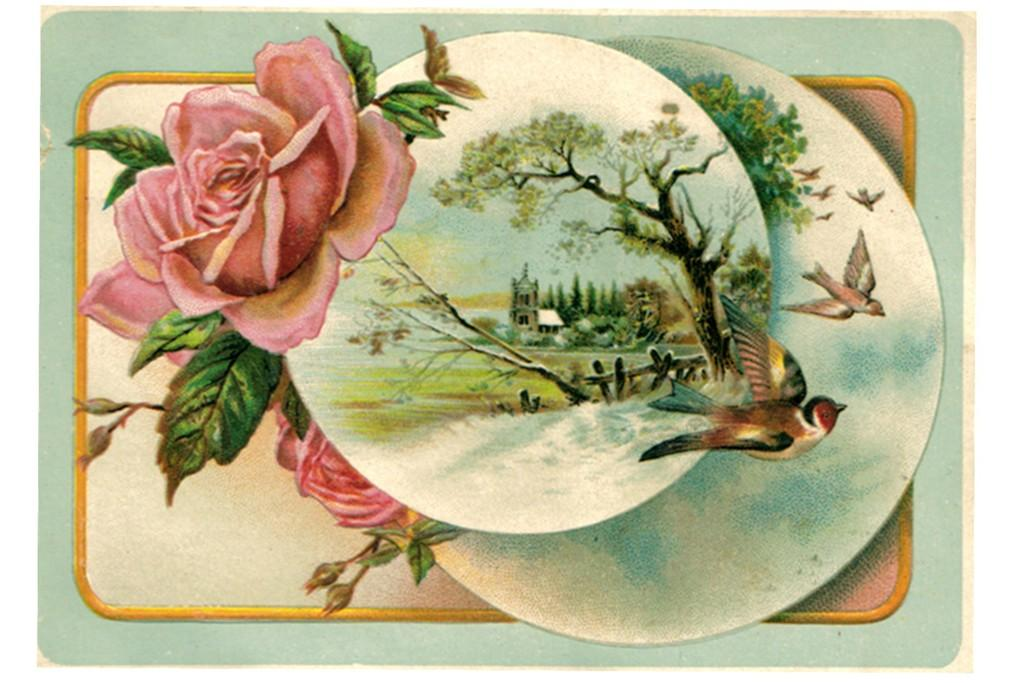What is the main subject of the image? There is a painting in the image. What can be seen in the painting? There are birds flying and a tree in the image. What other structures are visible in the image? There is a building in the image. Are there any plants or flowers in the image? Yes, there is a flower in the image. How many toes can be seen on the birds in the image? There are no visible toes on the birds in the image, as birds do not have toes like humans. 